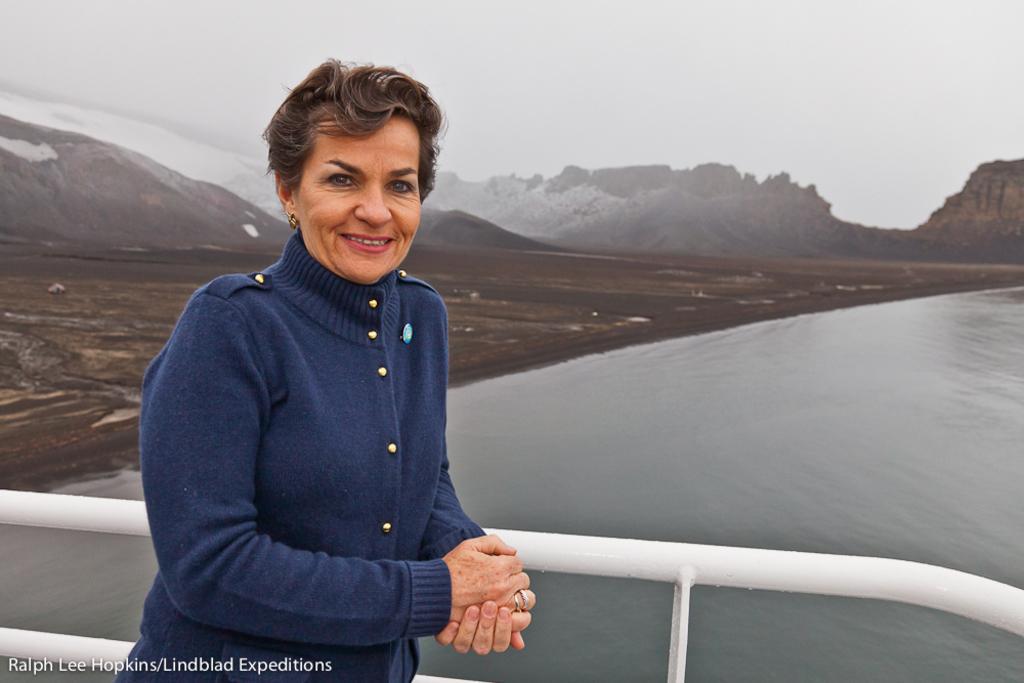Describe this image in one or two sentences. There is a woman in violet color t-shirt, smiling, standing and leaning on the white color fencing. In the background, there is water of the river, there is wet land, there are mountains and there are clouds in the sky. 